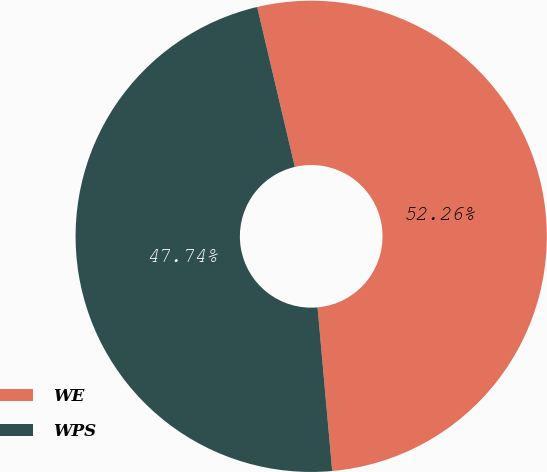Convert chart to OTSL. <chart><loc_0><loc_0><loc_500><loc_500><pie_chart><fcel>WE<fcel>WPS<nl><fcel>52.26%<fcel>47.74%<nl></chart> 